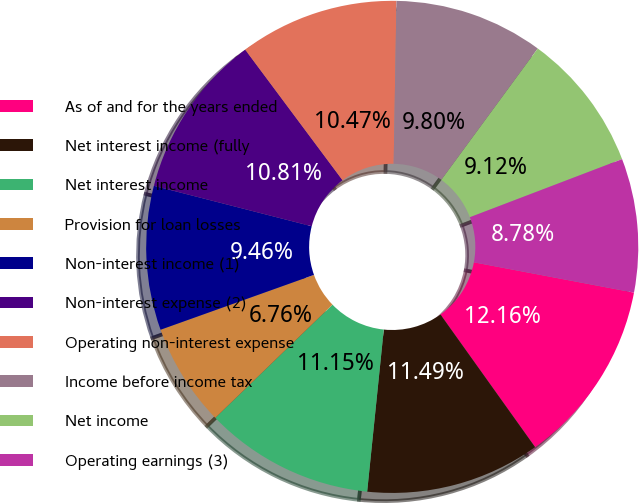<chart> <loc_0><loc_0><loc_500><loc_500><pie_chart><fcel>As of and for the years ended<fcel>Net interest income (fully<fcel>Net interest income<fcel>Provision for loan losses<fcel>Non-interest income (1)<fcel>Non-interest expense (2)<fcel>Operating non-interest expense<fcel>Income before income tax<fcel>Net income<fcel>Operating earnings (3)<nl><fcel>12.16%<fcel>11.49%<fcel>11.15%<fcel>6.76%<fcel>9.46%<fcel>10.81%<fcel>10.47%<fcel>9.8%<fcel>9.12%<fcel>8.78%<nl></chart> 